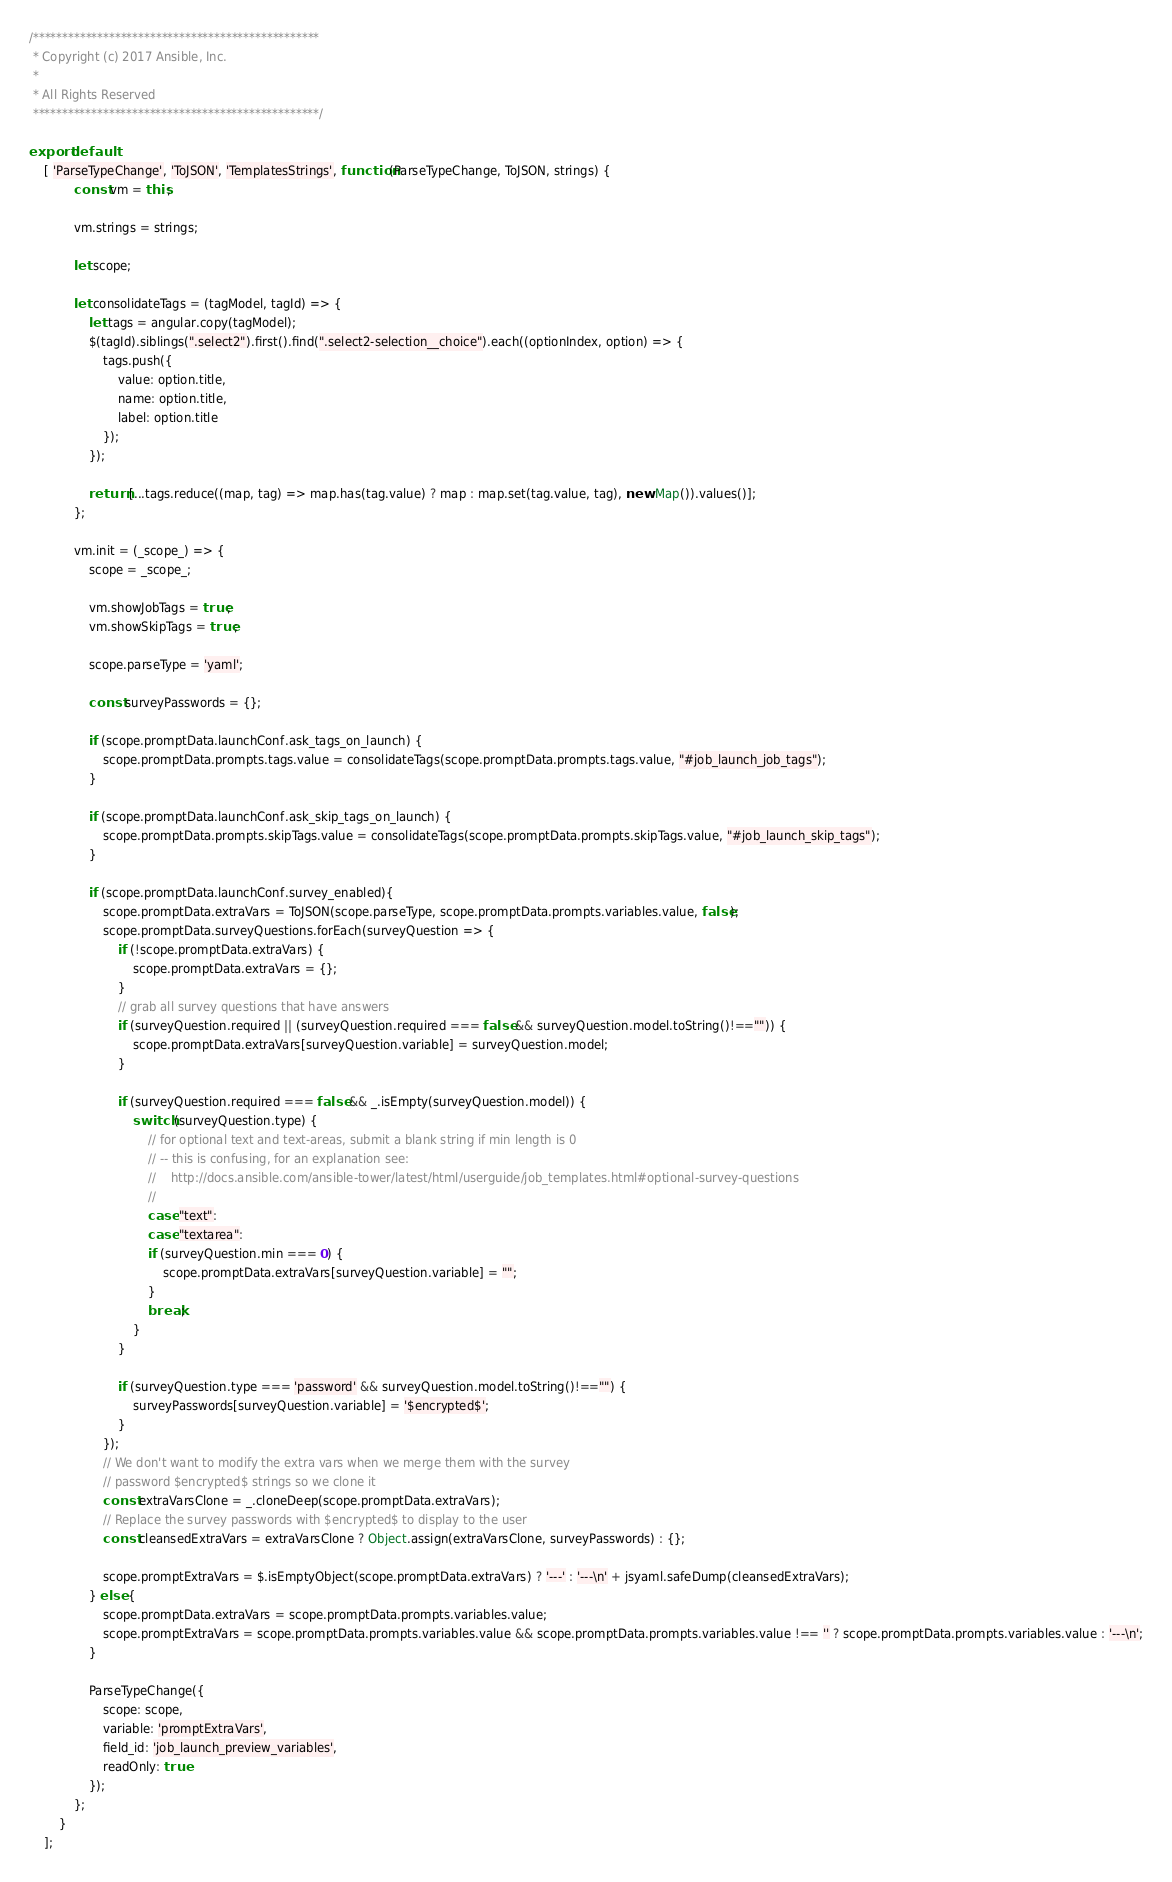<code> <loc_0><loc_0><loc_500><loc_500><_JavaScript_>/*************************************************
 * Copyright (c) 2017 Ansible, Inc.
 *
 * All Rights Reserved
 *************************************************/

export default
    [ 'ParseTypeChange', 'ToJSON', 'TemplatesStrings', function(ParseTypeChange, ToJSON, strings) {
            const vm = this;

            vm.strings = strings;

            let scope;

            let consolidateTags = (tagModel, tagId) => {
                let tags = angular.copy(tagModel);
                $(tagId).siblings(".select2").first().find(".select2-selection__choice").each((optionIndex, option) => {
                    tags.push({
                        value: option.title,
                        name: option.title,
                        label: option.title
                    });
                });

                return [...tags.reduce((map, tag) => map.has(tag.value) ? map : map.set(tag.value, tag), new Map()).values()];
            };

            vm.init = (_scope_) => {
                scope = _scope_;

                vm.showJobTags = true;
                vm.showSkipTags = true;

                scope.parseType = 'yaml';

                const surveyPasswords = {};

                if (scope.promptData.launchConf.ask_tags_on_launch) {
                    scope.promptData.prompts.tags.value = consolidateTags(scope.promptData.prompts.tags.value, "#job_launch_job_tags");
                }

                if (scope.promptData.launchConf.ask_skip_tags_on_launch) {
                    scope.promptData.prompts.skipTags.value = consolidateTags(scope.promptData.prompts.skipTags.value, "#job_launch_skip_tags");
                }

                if (scope.promptData.launchConf.survey_enabled){
                    scope.promptData.extraVars = ToJSON(scope.parseType, scope.promptData.prompts.variables.value, false);
                    scope.promptData.surveyQuestions.forEach(surveyQuestion => {
                        if (!scope.promptData.extraVars) {
                            scope.promptData.extraVars = {};
                        }
                        // grab all survey questions that have answers
                        if (surveyQuestion.required || (surveyQuestion.required === false && surveyQuestion.model.toString()!=="")) {
                            scope.promptData.extraVars[surveyQuestion.variable] = surveyQuestion.model;
                        }

                        if (surveyQuestion.required === false && _.isEmpty(surveyQuestion.model)) {
                            switch (surveyQuestion.type) {
                                // for optional text and text-areas, submit a blank string if min length is 0
                                // -- this is confusing, for an explanation see:
                                //    http://docs.ansible.com/ansible-tower/latest/html/userguide/job_templates.html#optional-survey-questions
                                //
                                case "text":
                                case "textarea":
                                if (surveyQuestion.min === 0) {
                                    scope.promptData.extraVars[surveyQuestion.variable] = "";
                                }
                                break;
                            }
                        }

                        if (surveyQuestion.type === 'password' && surveyQuestion.model.toString()!=="") {
                            surveyPasswords[surveyQuestion.variable] = '$encrypted$';
                        }
                    });
                    // We don't want to modify the extra vars when we merge them with the survey
                    // password $encrypted$ strings so we clone it
                    const extraVarsClone = _.cloneDeep(scope.promptData.extraVars);
                    // Replace the survey passwords with $encrypted$ to display to the user
                    const cleansedExtraVars = extraVarsClone ? Object.assign(extraVarsClone, surveyPasswords) : {};

                    scope.promptExtraVars = $.isEmptyObject(scope.promptData.extraVars) ? '---' : '---\n' + jsyaml.safeDump(cleansedExtraVars);
                } else {
                    scope.promptData.extraVars = scope.promptData.prompts.variables.value;
                    scope.promptExtraVars = scope.promptData.prompts.variables.value && scope.promptData.prompts.variables.value !== '' ? scope.promptData.prompts.variables.value : '---\n';
                }

                ParseTypeChange({
                    scope: scope,
                    variable: 'promptExtraVars',
                    field_id: 'job_launch_preview_variables',
                    readOnly: true
                });
            };
        }
    ];
</code> 